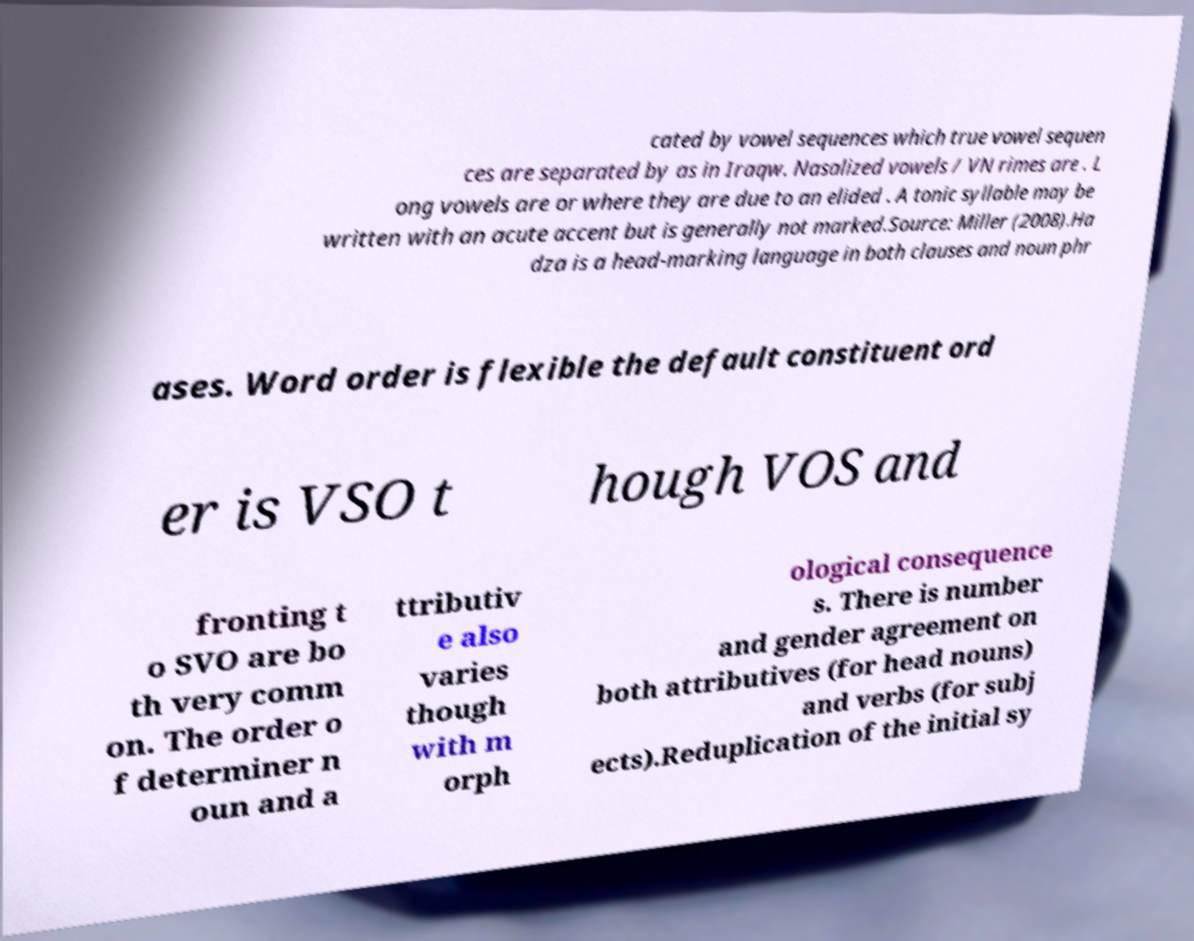Please read and relay the text visible in this image. What does it say? cated by vowel sequences which true vowel sequen ces are separated by as in Iraqw. Nasalized vowels / VN rimes are . L ong vowels are or where they are due to an elided . A tonic syllable may be written with an acute accent but is generally not marked.Source: Miller (2008).Ha dza is a head-marking language in both clauses and noun phr ases. Word order is flexible the default constituent ord er is VSO t hough VOS and fronting t o SVO are bo th very comm on. The order o f determiner n oun and a ttributiv e also varies though with m orph ological consequence s. There is number and gender agreement on both attributives (for head nouns) and verbs (for subj ects).Reduplication of the initial sy 